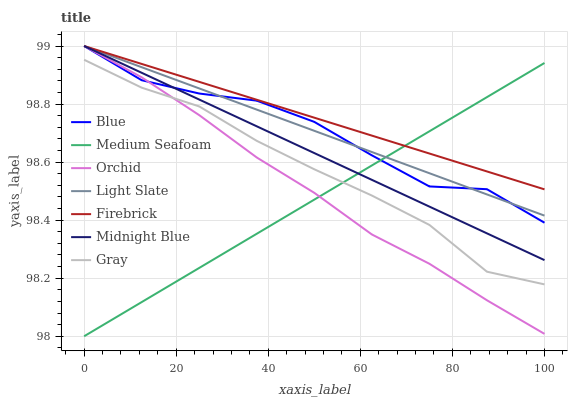Does Medium Seafoam have the minimum area under the curve?
Answer yes or no. Yes. Does Firebrick have the maximum area under the curve?
Answer yes or no. Yes. Does Gray have the minimum area under the curve?
Answer yes or no. No. Does Gray have the maximum area under the curve?
Answer yes or no. No. Is Medium Seafoam the smoothest?
Answer yes or no. Yes. Is Blue the roughest?
Answer yes or no. Yes. Is Gray the smoothest?
Answer yes or no. No. Is Gray the roughest?
Answer yes or no. No. Does Medium Seafoam have the lowest value?
Answer yes or no. Yes. Does Gray have the lowest value?
Answer yes or no. No. Does Orchid have the highest value?
Answer yes or no. Yes. Does Gray have the highest value?
Answer yes or no. No. Is Gray less than Midnight Blue?
Answer yes or no. Yes. Is Midnight Blue greater than Gray?
Answer yes or no. Yes. Does Medium Seafoam intersect Orchid?
Answer yes or no. Yes. Is Medium Seafoam less than Orchid?
Answer yes or no. No. Is Medium Seafoam greater than Orchid?
Answer yes or no. No. Does Gray intersect Midnight Blue?
Answer yes or no. No. 